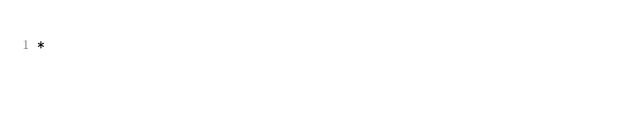Convert code to text. <code><loc_0><loc_0><loc_500><loc_500><_JavaScript_>*
</code> 